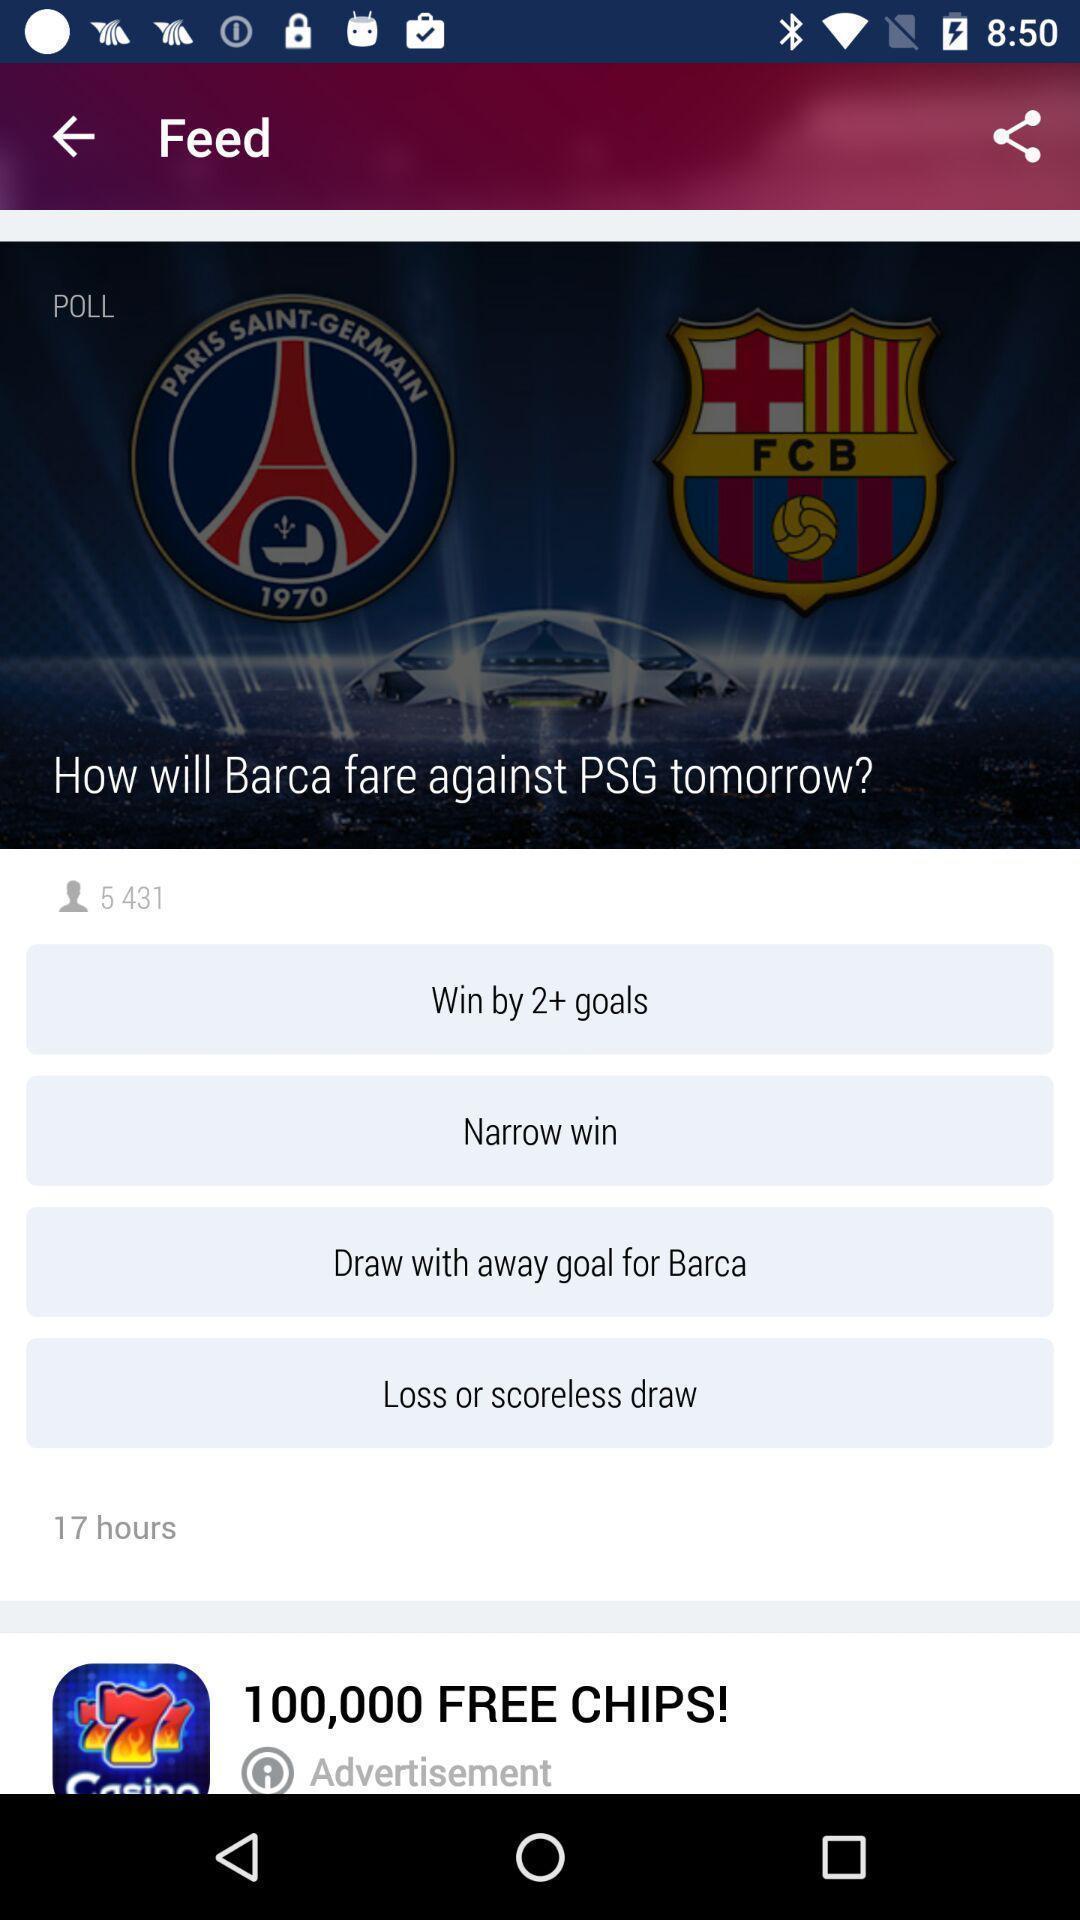What is the overall content of this screenshot? Screen showing feed. 